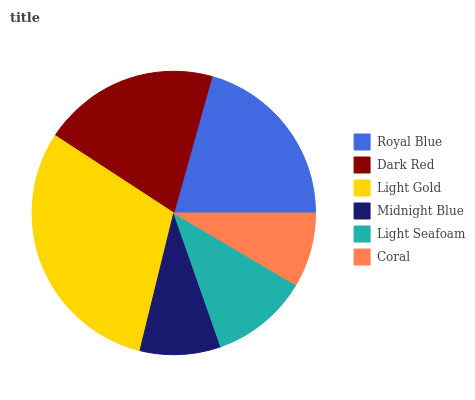Is Coral the minimum?
Answer yes or no. Yes. Is Light Gold the maximum?
Answer yes or no. Yes. Is Dark Red the minimum?
Answer yes or no. No. Is Dark Red the maximum?
Answer yes or no. No. Is Royal Blue greater than Dark Red?
Answer yes or no. Yes. Is Dark Red less than Royal Blue?
Answer yes or no. Yes. Is Dark Red greater than Royal Blue?
Answer yes or no. No. Is Royal Blue less than Dark Red?
Answer yes or no. No. Is Dark Red the high median?
Answer yes or no. Yes. Is Light Seafoam the low median?
Answer yes or no. Yes. Is Midnight Blue the high median?
Answer yes or no. No. Is Royal Blue the low median?
Answer yes or no. No. 